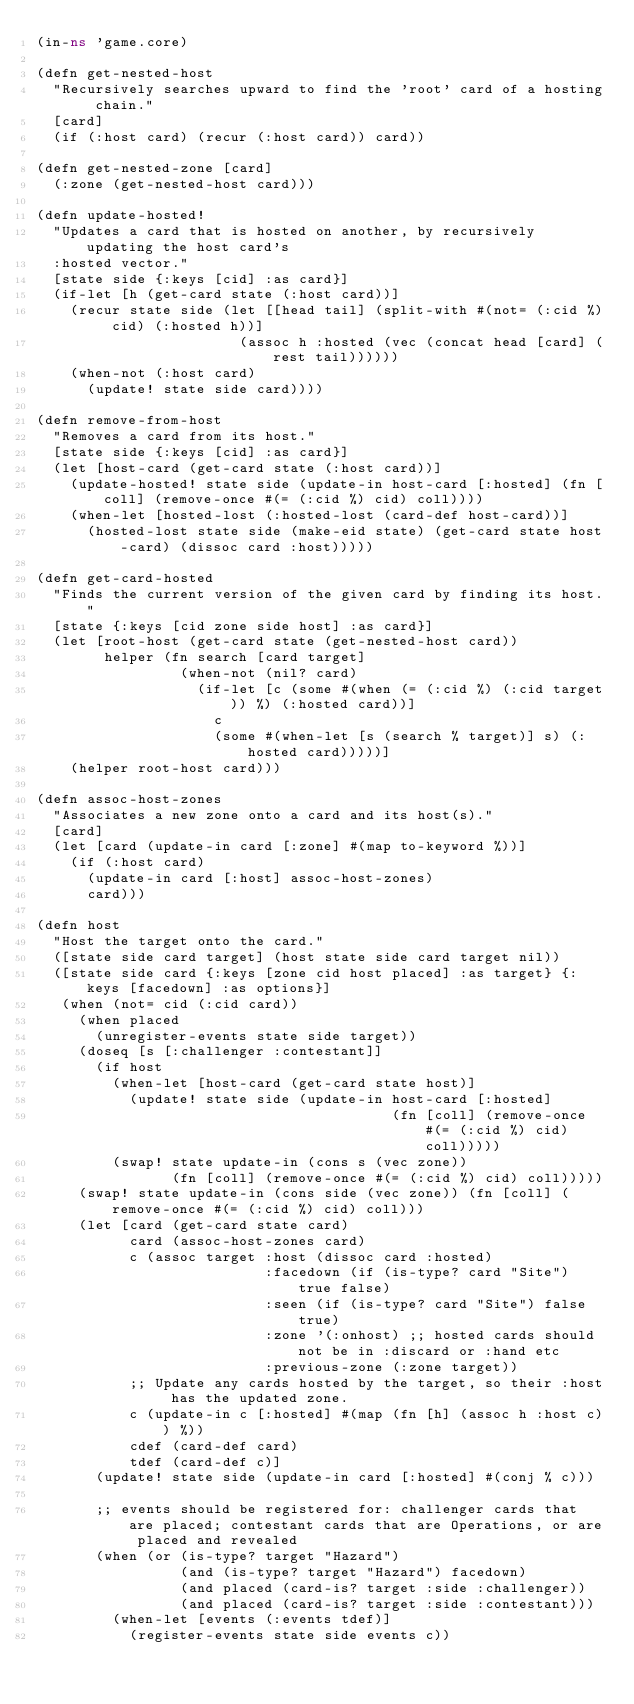<code> <loc_0><loc_0><loc_500><loc_500><_Clojure_>(in-ns 'game.core)

(defn get-nested-host
  "Recursively searches upward to find the 'root' card of a hosting chain."
  [card]
  (if (:host card) (recur (:host card)) card))

(defn get-nested-zone [card]
  (:zone (get-nested-host card)))

(defn update-hosted!
  "Updates a card that is hosted on another, by recursively updating the host card's
  :hosted vector."
  [state side {:keys [cid] :as card}]
  (if-let [h (get-card state (:host card))]
    (recur state side (let [[head tail] (split-with #(not= (:cid %) cid) (:hosted h))]
                        (assoc h :hosted (vec (concat head [card] (rest tail))))))
    (when-not (:host card)
      (update! state side card))))

(defn remove-from-host
  "Removes a card from its host."
  [state side {:keys [cid] :as card}]
  (let [host-card (get-card state (:host card))]
    (update-hosted! state side (update-in host-card [:hosted] (fn [coll] (remove-once #(= (:cid %) cid) coll))))
    (when-let [hosted-lost (:hosted-lost (card-def host-card))]
      (hosted-lost state side (make-eid state) (get-card state host-card) (dissoc card :host)))))

(defn get-card-hosted
  "Finds the current version of the given card by finding its host."
  [state {:keys [cid zone side host] :as card}]
  (let [root-host (get-card state (get-nested-host card))
        helper (fn search [card target]
                 (when-not (nil? card)
                   (if-let [c (some #(when (= (:cid %) (:cid target)) %) (:hosted card))]
                     c
                     (some #(when-let [s (search % target)] s) (:hosted card)))))]
    (helper root-host card)))

(defn assoc-host-zones
  "Associates a new zone onto a card and its host(s)."
  [card]
  (let [card (update-in card [:zone] #(map to-keyword %))]
    (if (:host card)
      (update-in card [:host] assoc-host-zones)
      card)))

(defn host
  "Host the target onto the card."
  ([state side card target] (host state side card target nil))
  ([state side card {:keys [zone cid host placed] :as target} {:keys [facedown] :as options}]
   (when (not= cid (:cid card))
     (when placed
       (unregister-events state side target))
     (doseq [s [:challenger :contestant]]
       (if host
         (when-let [host-card (get-card state host)]
           (update! state side (update-in host-card [:hosted]
                                          (fn [coll] (remove-once #(= (:cid %) cid) coll)))))
         (swap! state update-in (cons s (vec zone))
                (fn [coll] (remove-once #(= (:cid %) cid) coll)))))
     (swap! state update-in (cons side (vec zone)) (fn [coll] (remove-once #(= (:cid %) cid) coll)))
     (let [card (get-card state card)
           card (assoc-host-zones card)
           c (assoc target :host (dissoc card :hosted)
                           :facedown (if (is-type? card "Site") true false)
                           :seen (if (is-type? card "Site") false true)
                           :zone '(:onhost) ;; hosted cards should not be in :discard or :hand etc
                           :previous-zone (:zone target))
           ;; Update any cards hosted by the target, so their :host has the updated zone.
           c (update-in c [:hosted] #(map (fn [h] (assoc h :host c)) %))
           cdef (card-def card)
           tdef (card-def c)]
       (update! state side (update-in card [:hosted] #(conj % c)))

       ;; events should be registered for: challenger cards that are placed; contestant cards that are Operations, or are placed and revealed
       (when (or (is-type? target "Hazard")
                 (and (is-type? target "Hazard") facedown)
                 (and placed (card-is? target :side :challenger))
                 (and placed (card-is? target :side :contestant)))
         (when-let [events (:events tdef)]
           (register-events state side events c))</code> 